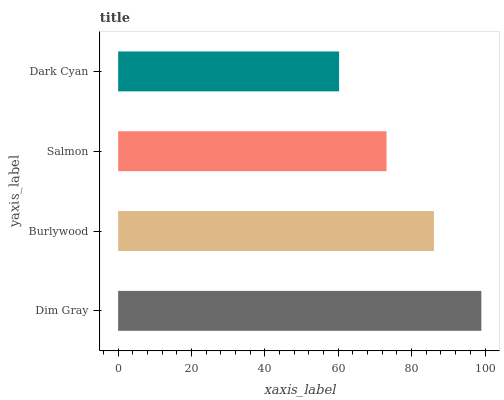Is Dark Cyan the minimum?
Answer yes or no. Yes. Is Dim Gray the maximum?
Answer yes or no. Yes. Is Burlywood the minimum?
Answer yes or no. No. Is Burlywood the maximum?
Answer yes or no. No. Is Dim Gray greater than Burlywood?
Answer yes or no. Yes. Is Burlywood less than Dim Gray?
Answer yes or no. Yes. Is Burlywood greater than Dim Gray?
Answer yes or no. No. Is Dim Gray less than Burlywood?
Answer yes or no. No. Is Burlywood the high median?
Answer yes or no. Yes. Is Salmon the low median?
Answer yes or no. Yes. Is Salmon the high median?
Answer yes or no. No. Is Dim Gray the low median?
Answer yes or no. No. 